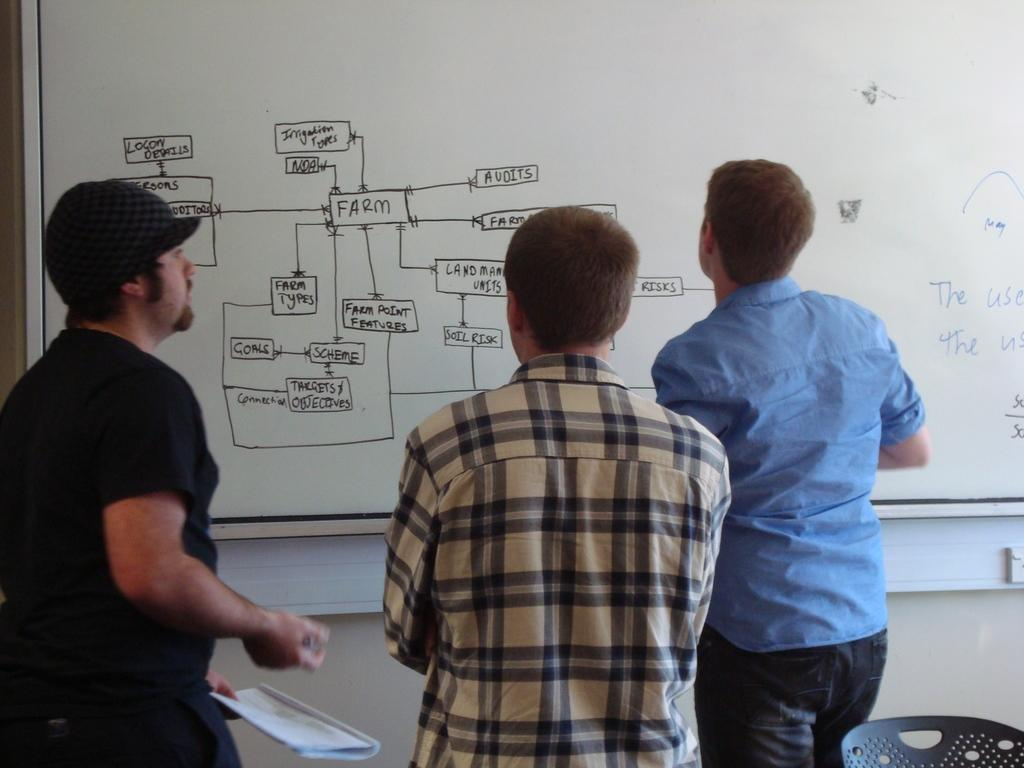<image>
Summarize the visual content of the image. Students looking at a flow chart about a farm on a whiteboard. 